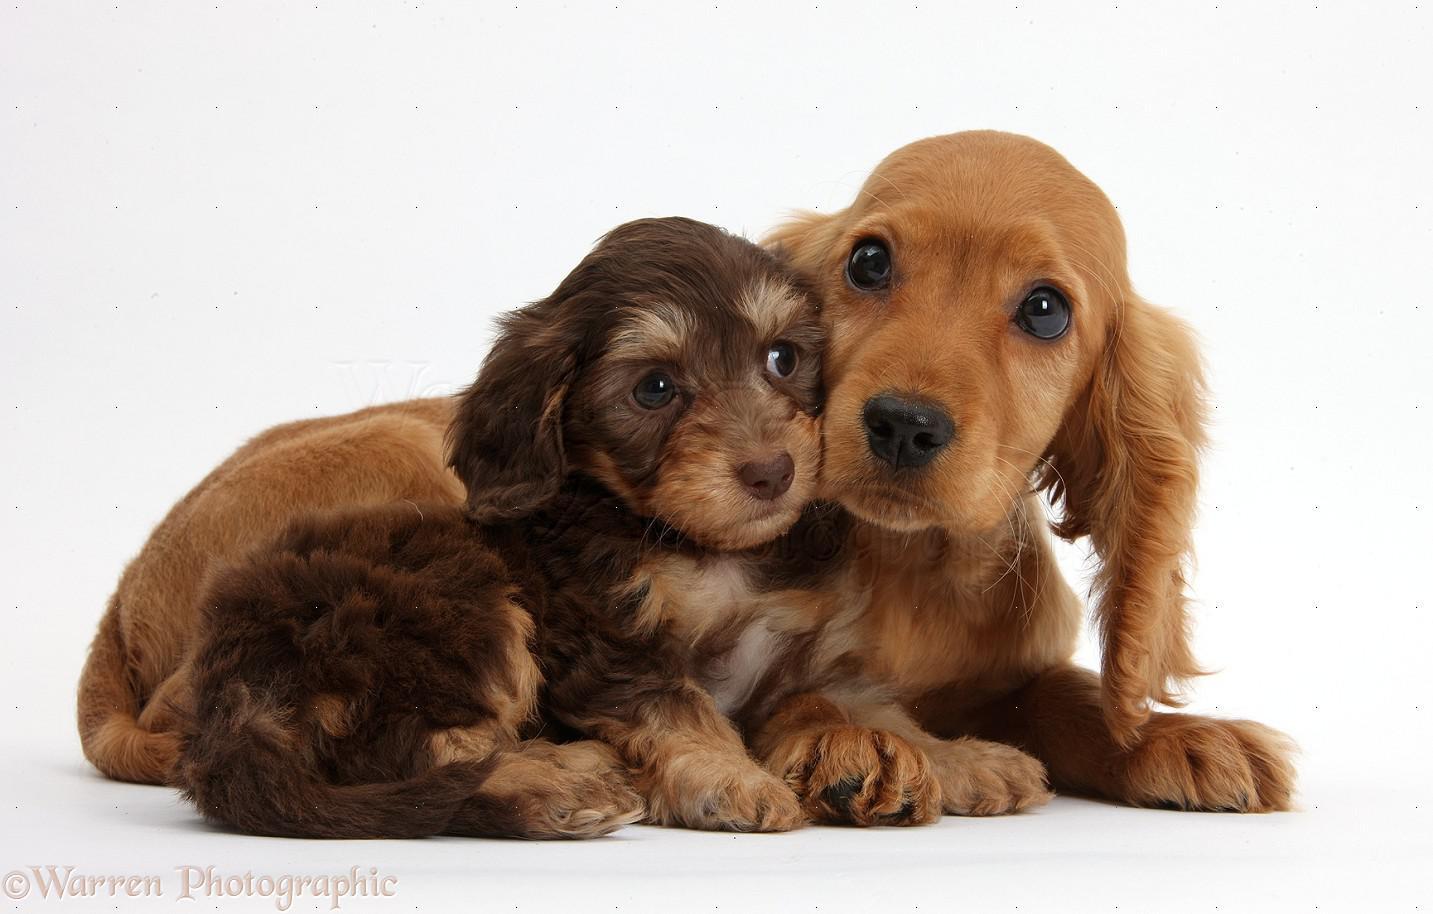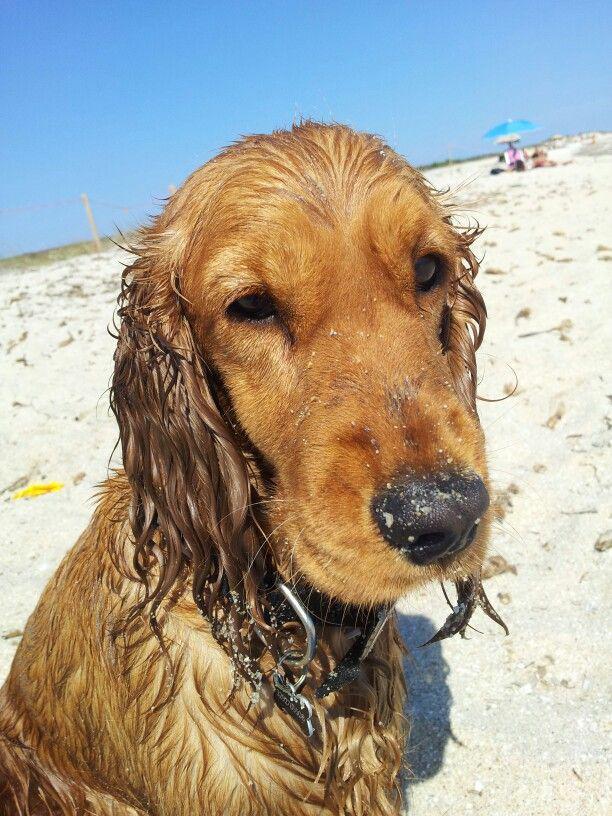The first image is the image on the left, the second image is the image on the right. Assess this claim about the two images: "There are no more than 3 dogs.". Correct or not? Answer yes or no. Yes. The first image is the image on the left, the second image is the image on the right. Evaluate the accuracy of this statement regarding the images: "The right image contains exactly three dogs.". Is it true? Answer yes or no. No. 